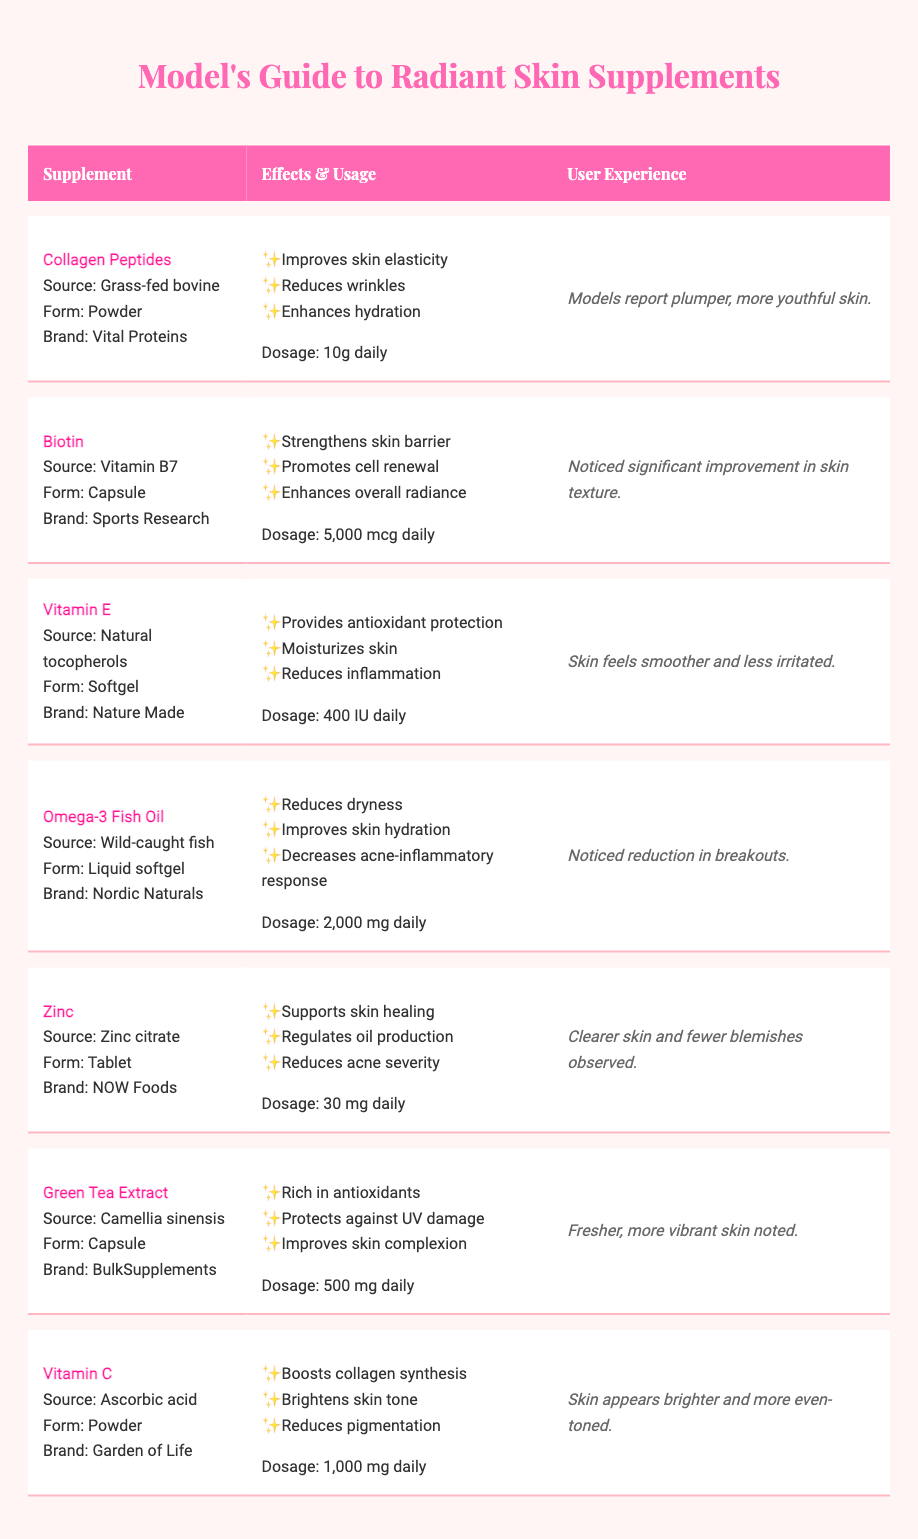What is the main effect of taking Collagen Peptides? The table lists the main effects of Collagen Peptides, which include improving skin elasticity, reducing wrinkles, and enhancing hydration.
Answer: Improves skin elasticity, reduces wrinkles, enhances hydration How much Biotin should be taken daily? According to the table, the recommended dosage for Biotin is 5,000 mcg daily.
Answer: 5,000 mcg daily Does Vitamin E help reduce skin inflammation? The table indicates that one of the main effects of Vitamin E is to reduce inflammation, so the answer is yes.
Answer: Yes What form does Omega-3 Fish Oil come in? The table specifies that Omega-3 Fish Oil is provided in a liquid softgel form.
Answer: Liquid softgel Which supplement has the user experience reporting clearer skin and fewer blemishes? From the user experience listed, Zinc is noted for resulting in clearer skin and fewer blemishes observed.
Answer: Zinc Which supplements are taken in powder form? The table indicates that both Collagen Peptides and Vitamin C are taken in powder form.
Answer: Collagen Peptides, Vitamin C If a model combines Collagen Peptides and Vitamin C, what combined effects can they expect based on the table? Collagen Peptides can improve skin elasticity and hydration, while Vitamin C boosts collagen synthesis and brightens the skin tone. Therefore, combining these could lead to enhanced skin elasticity, hydration, and a brighter complexion.
Answer: Enhanced skin elasticity, hydration, and brighter complexion What is the difference in dosage between Zinc and Omega-3 Fish Oil? Zinc has a dosage of 30 mg daily, while Omega-3 Fish Oil has a dosage of 2,000 mg daily. The difference in dosage is therefore 2,000 mg - 30 mg = 1,970 mg.
Answer: 1,970 mg Which supplement is noted for providing antioxidant protection and moisturizing the skin? The table shows that Vitamin E provides antioxidant protection and also moisturizes the skin.
Answer: Vitamin E How many supplements noted provide improvement in skin complexion or radiance? The table mentions that Biotin, Green Tea Extract, and Vitamin C all have effects related to enhancing overall radiance or improving skin complexion, totaling three supplements.
Answer: Three supplements Which supplement has the highest user-reported satisfaction regarding skin hydration? Based on user experiences, Omega-3 Fish Oil is noted for its improvement in skin hydration.
Answer: Omega-3 Fish Oil 